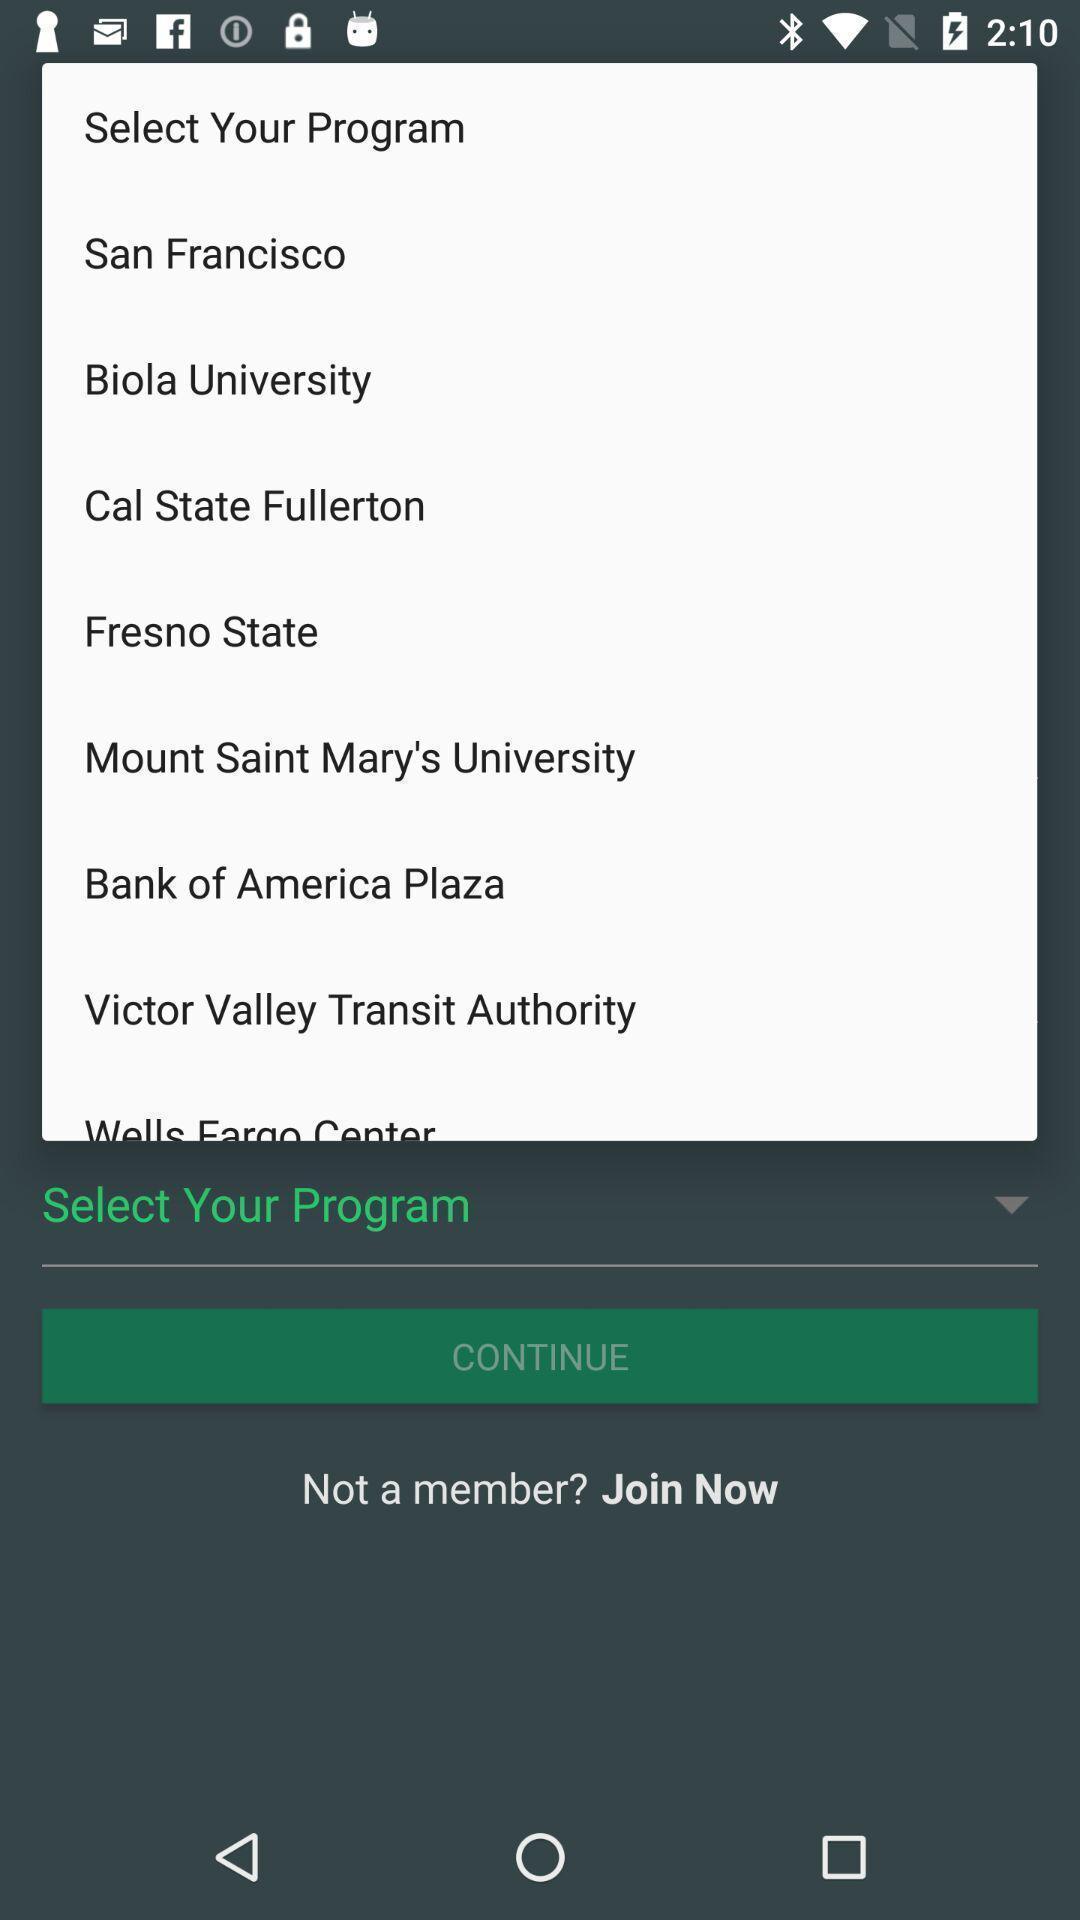Tell me about the visual elements in this screen capture. Screen shows list of dropdown option. 